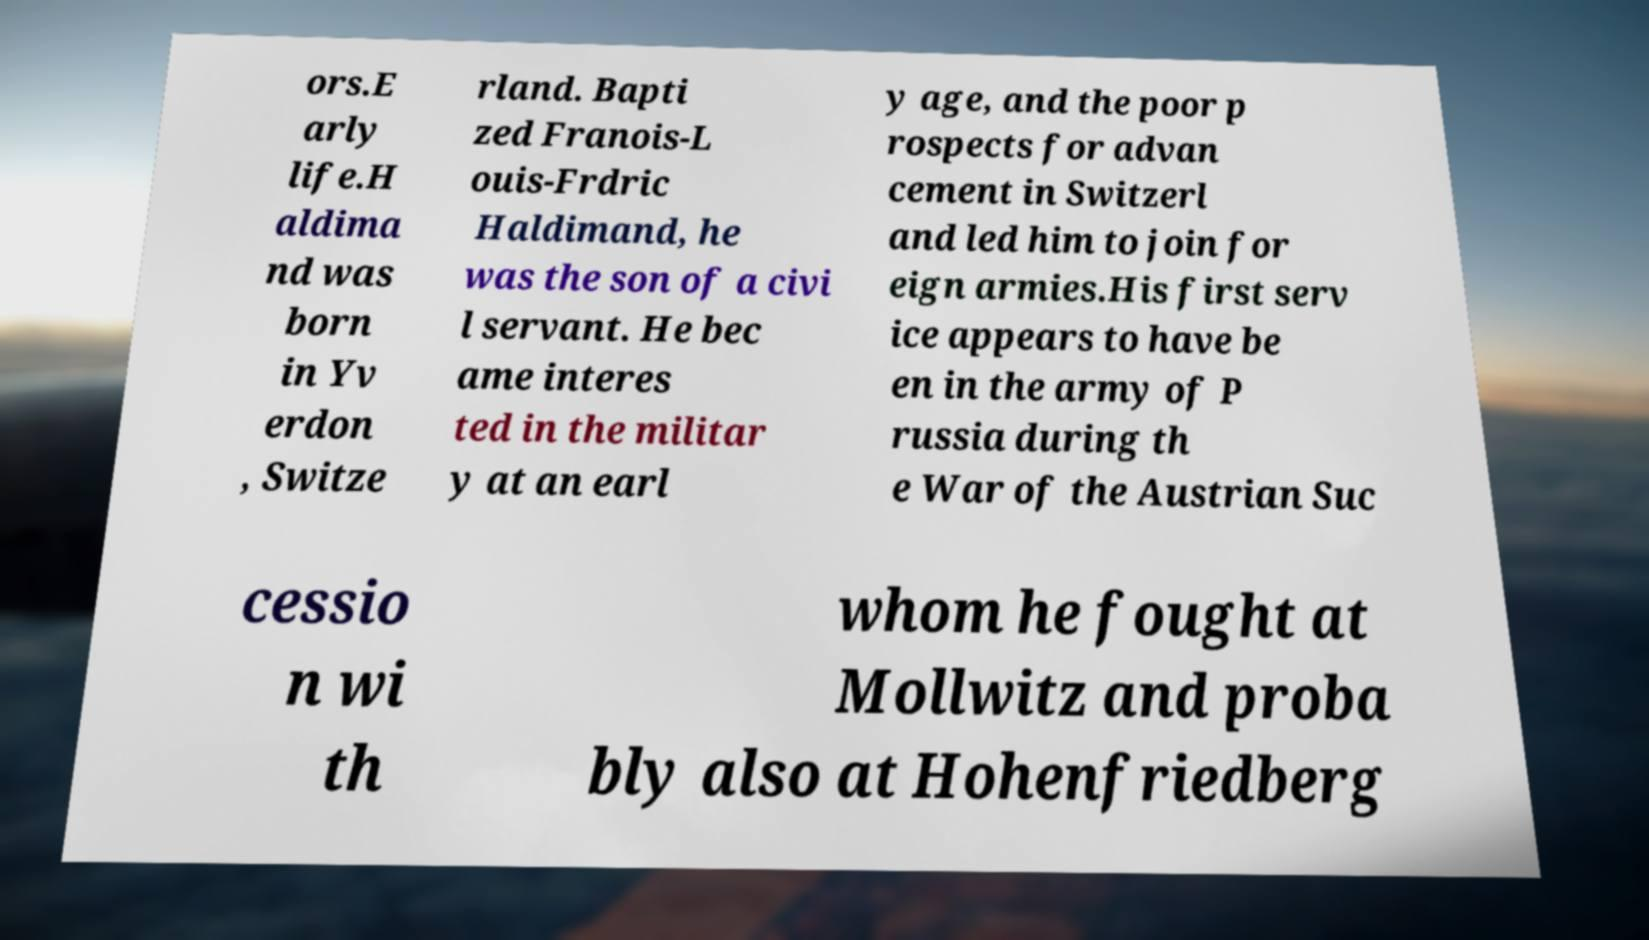What messages or text are displayed in this image? I need them in a readable, typed format. ors.E arly life.H aldima nd was born in Yv erdon , Switze rland. Bapti zed Franois-L ouis-Frdric Haldimand, he was the son of a civi l servant. He bec ame interes ted in the militar y at an earl y age, and the poor p rospects for advan cement in Switzerl and led him to join for eign armies.His first serv ice appears to have be en in the army of P russia during th e War of the Austrian Suc cessio n wi th whom he fought at Mollwitz and proba bly also at Hohenfriedberg 